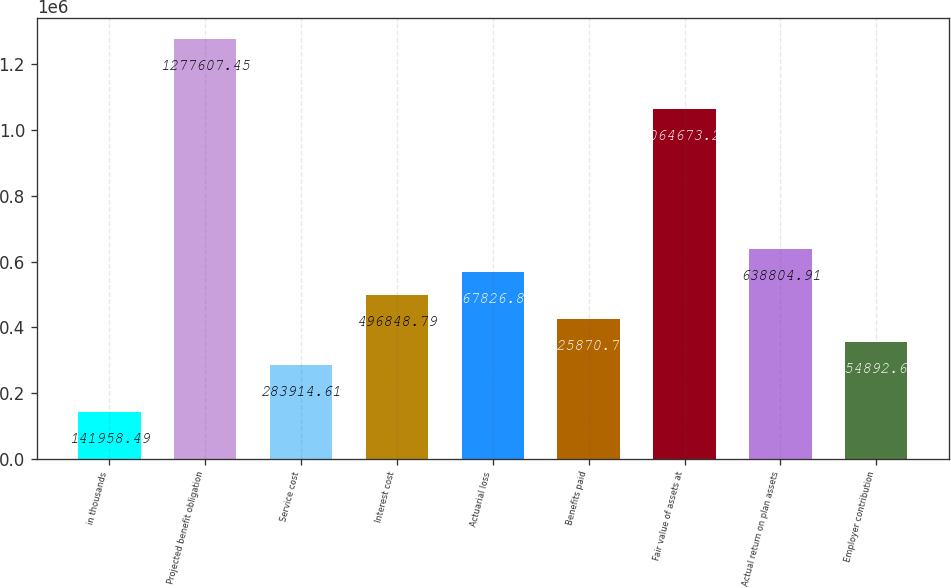<chart> <loc_0><loc_0><loc_500><loc_500><bar_chart><fcel>in thousands<fcel>Projected benefit obligation<fcel>Service cost<fcel>Interest cost<fcel>Actuarial loss<fcel>Benefits paid<fcel>Fair value of assets at<fcel>Actual return on plan assets<fcel>Employer contribution<nl><fcel>141958<fcel>1.27761e+06<fcel>283915<fcel>496849<fcel>567827<fcel>425871<fcel>1.06467e+06<fcel>638805<fcel>354893<nl></chart> 